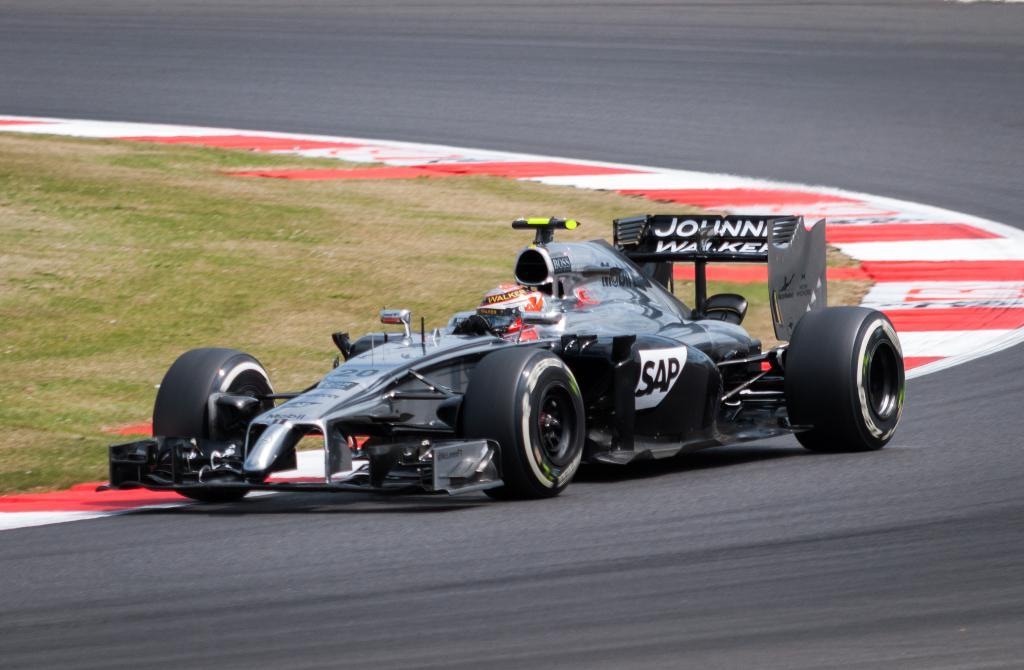What is the main subject of the image? The main subject of the image is a racing car. Where is the racing car located in the image? The car is on an empty road. What type of surface is visible behind the car? There is a grass surface visible behind the car. What type of screw can be seen holding the racing car together in the image? There is no screw visible in the image; it is a photograph of a racing car on an empty road. What color is the mist surrounding the racing car in the image? There is no mist present in the image; it is a clear image of a racing car on an empty road. 